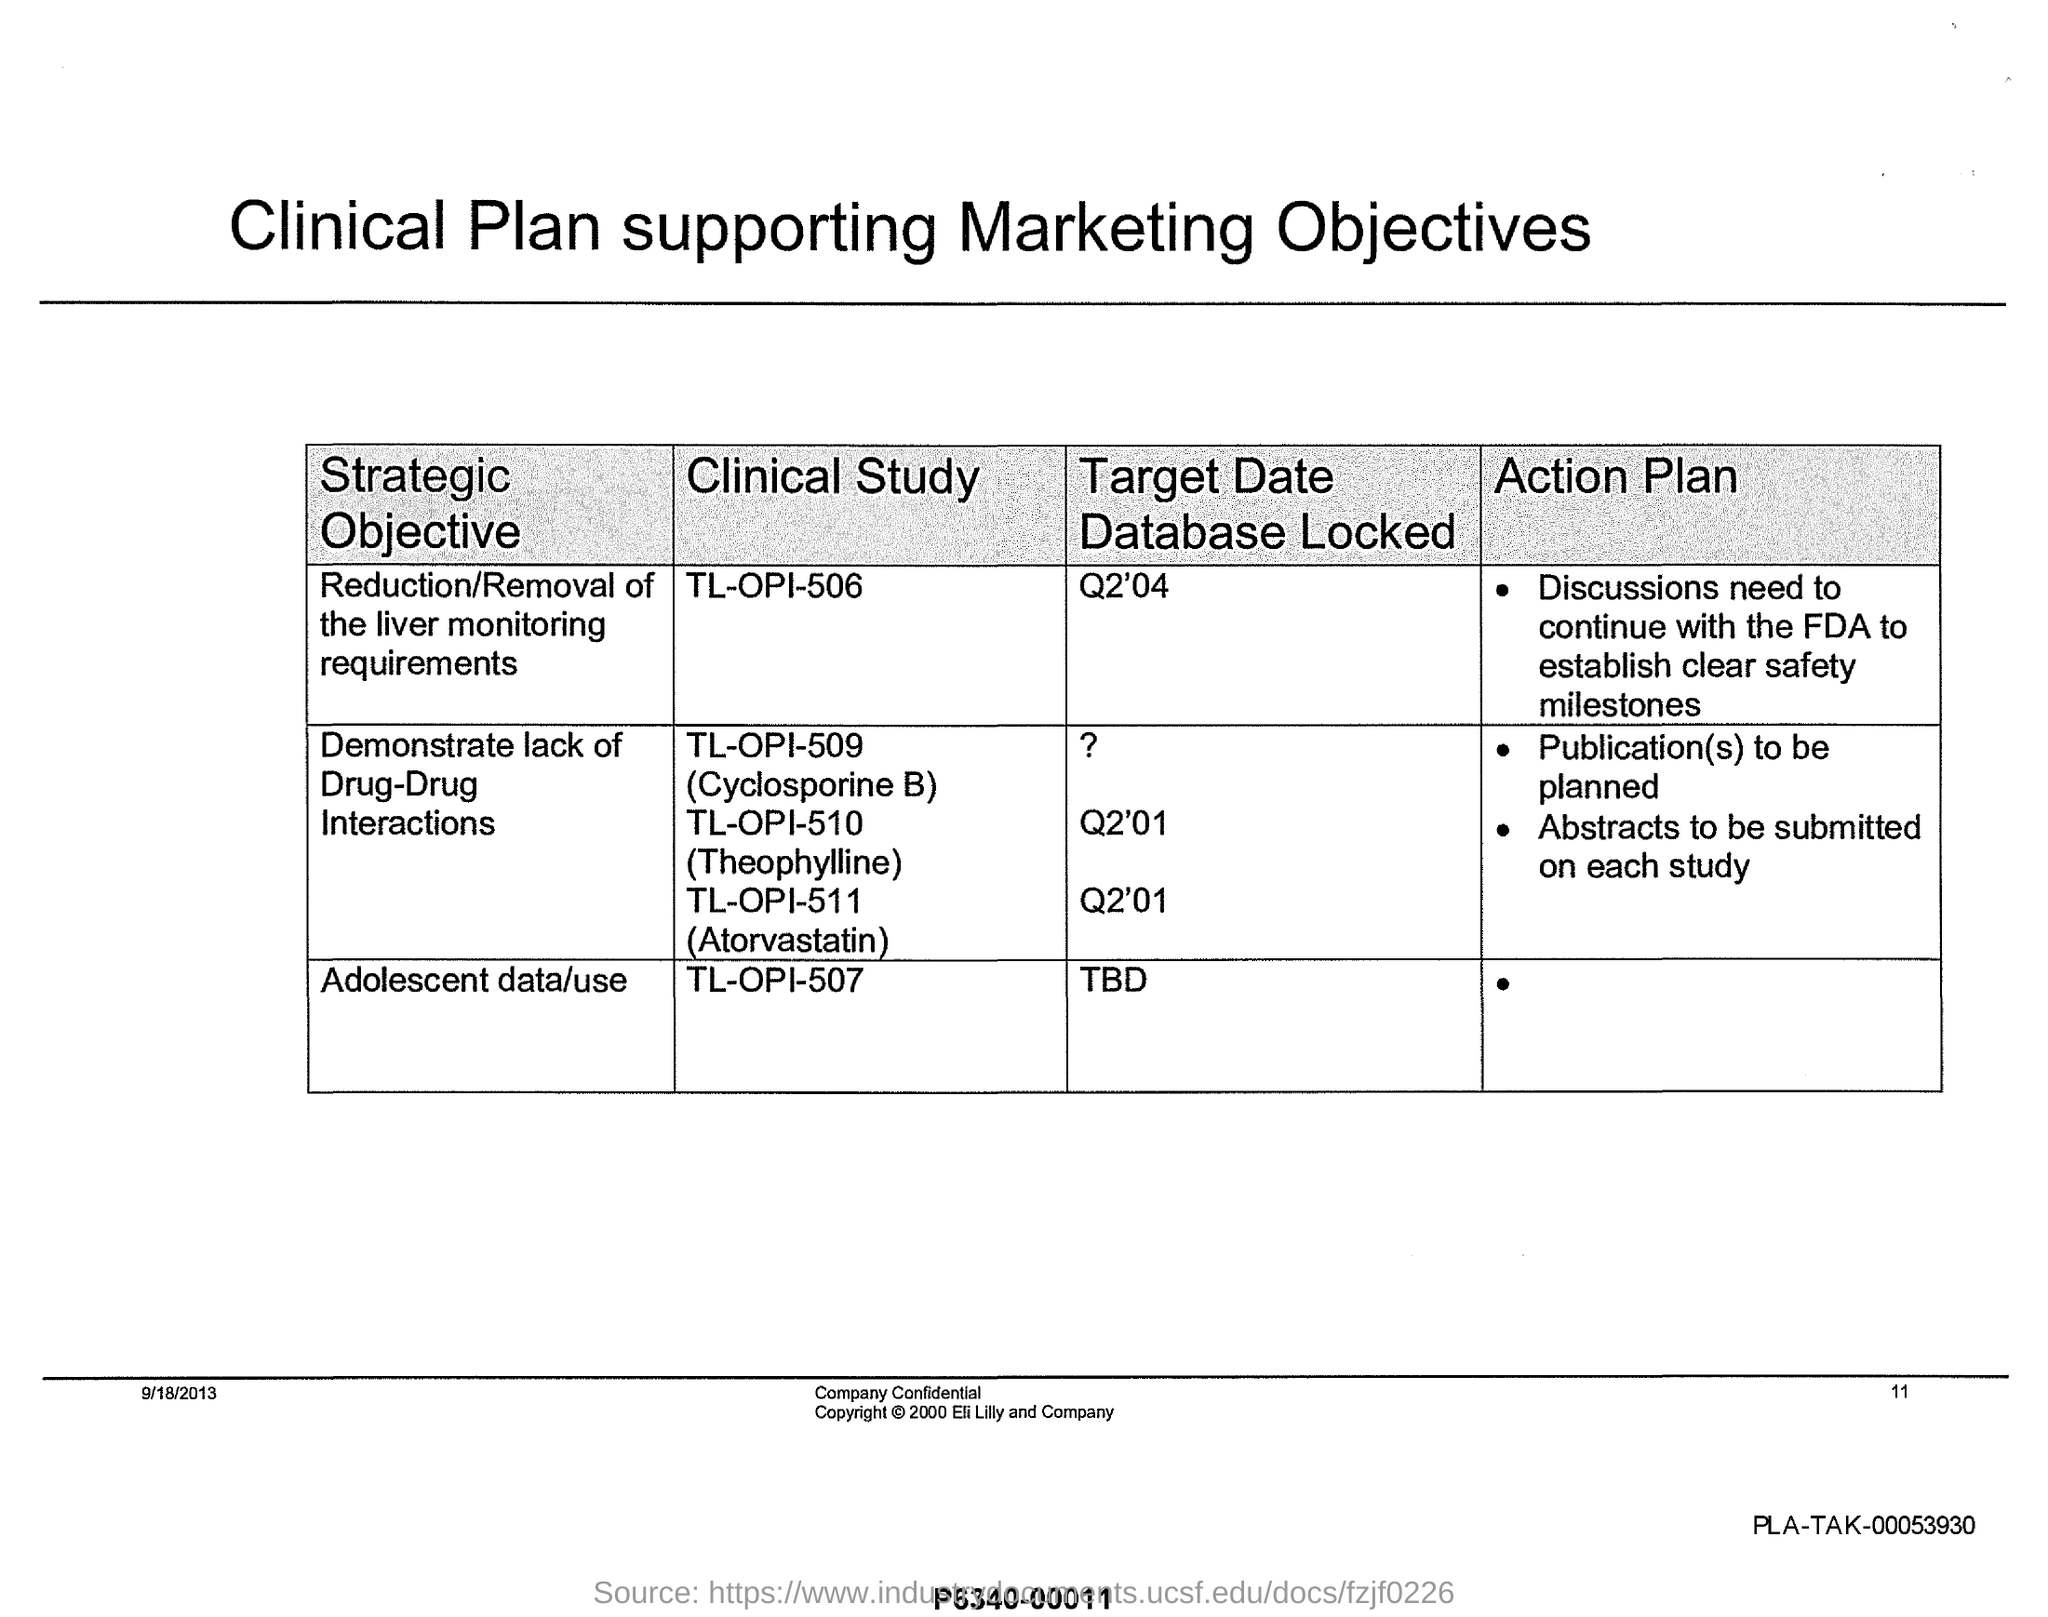Mention a couple of crucial points in this snapshot. The "Target Date Database Locked" for "Adolescent data/use" is currently unknown. The first column of the table is titled 'Strategic Objective', indicating its importance in the strategic planning process. The heading of the fourth column of the table is "Action Plan. The heading of the table at the top of the page is "Clinical Plan supporting Marketing Objectives. The "PLA-TAK" number mentioned at the bottom right of the page is a unique identifier consisting of letters and numbers, specifically PLA-TAK-00053930. 